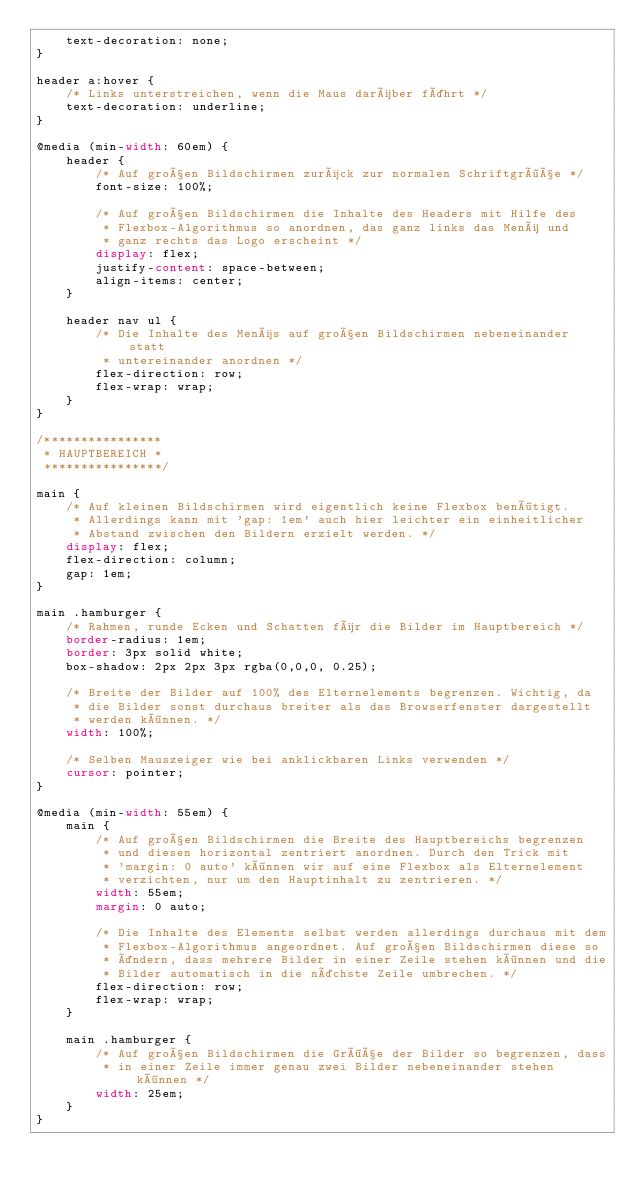Convert code to text. <code><loc_0><loc_0><loc_500><loc_500><_CSS_>    text-decoration: none;
}

header a:hover {
    /* Links unterstreichen, wenn die Maus darüber fährt */
    text-decoration: underline;
}

@media (min-width: 60em) {
    header {
        /* Auf großen Bildschirmen zurück zur normalen Schriftgröße */
        font-size: 100%;

        /* Auf großen Bildschirmen die Inhalte des Headers mit Hilfe des
         * Flexbox-Algorithmus so anordnen, das ganz links das Menü und
         * ganz rechts das Logo erscheint */
        display: flex;
        justify-content: space-between;
        align-items: center;
    }

    header nav ul {
        /* Die Inhalte des Menüs auf großen Bildschirmen nebeneinander statt
         * untereinander anordnen */
        flex-direction: row;
        flex-wrap: wrap;
    }
}

/****************
 * HAUPTBEREICH *
 ****************/

main {
    /* Auf kleinen Bildschirmen wird eigentlich keine Flexbox benötigt.
     * Allerdings kann mit 'gap: 1em' auch hier leichter ein einheitlicher
     * Abstand zwischen den Bildern erzielt werden. */
    display: flex;
    flex-direction: column;
    gap: 1em;
}

main .hamburger {
    /* Rahmen, runde Ecken und Schatten für die Bilder im Hauptbereich */
    border-radius: 1em;
    border: 3px solid white;
    box-shadow: 2px 2px 3px rgba(0,0,0, 0.25);

    /* Breite der Bilder auf 100% des Elternelements begrenzen. Wichtig, da
     * die Bilder sonst durchaus breiter als das Browserfenster dargestellt
     * werden können. */
    width: 100%;

    /* Selben Mauszeiger wie bei anklickbaren Links verwenden */
    cursor: pointer;
}

@media (min-width: 55em) {
    main {
        /* Auf großen Bildschirmen die Breite des Hauptbereichs begrenzen
         * und diesen horizontal zentriert anordnen. Durch den Trick mit
         * 'margin: 0 auto' können wir auf eine Flexbox als Elternelement
         * verzichten, nur um den Hauptinhalt zu zentrieren. */
        width: 55em;
        margin: 0 auto;

        /* Die Inhalte des Elements selbst werden allerdings durchaus mit dem
         * Flexbox-Algorithmus angeordnet. Auf großen Bildschirmen diese so
         * ändern, dass mehrere Bilder in einer Zeile stehen können und die
         * Bilder automatisch in die nächste Zeile umbrechen. */
        flex-direction: row;
        flex-wrap: wrap;
    }

    main .hamburger {
        /* Auf großen Bildschirmen die Größe der Bilder so begrenzen, dass
         * in einer Zeile immer genau zwei Bilder nebeneinander stehen können */
        width: 25em;
    }
}
</code> 